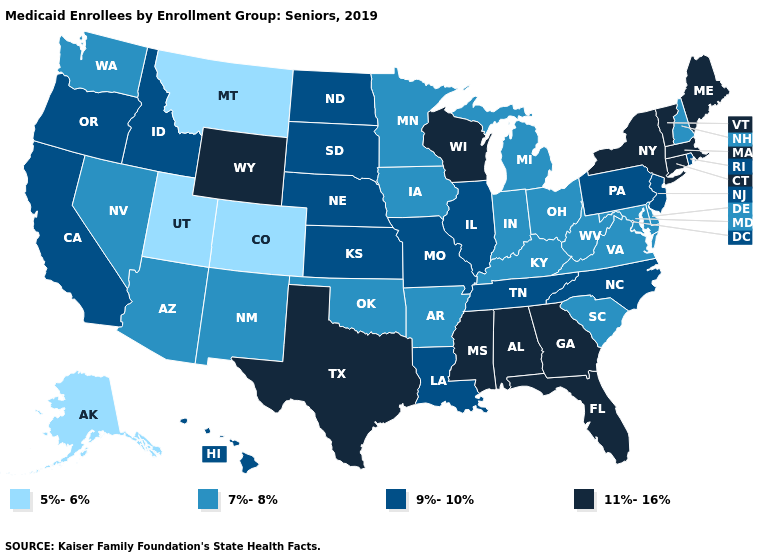Among the states that border South Dakota , does Wyoming have the highest value?
Short answer required. Yes. What is the value of Ohio?
Answer briefly. 7%-8%. Does the map have missing data?
Give a very brief answer. No. What is the value of Alaska?
Write a very short answer. 5%-6%. Among the states that border Texas , which have the lowest value?
Be succinct. Arkansas, New Mexico, Oklahoma. Name the states that have a value in the range 5%-6%?
Give a very brief answer. Alaska, Colorado, Montana, Utah. Name the states that have a value in the range 9%-10%?
Be succinct. California, Hawaii, Idaho, Illinois, Kansas, Louisiana, Missouri, Nebraska, New Jersey, North Carolina, North Dakota, Oregon, Pennsylvania, Rhode Island, South Dakota, Tennessee. Does the map have missing data?
Be succinct. No. Name the states that have a value in the range 5%-6%?
Give a very brief answer. Alaska, Colorado, Montana, Utah. What is the value of Connecticut?
Keep it brief. 11%-16%. Which states have the highest value in the USA?
Be succinct. Alabama, Connecticut, Florida, Georgia, Maine, Massachusetts, Mississippi, New York, Texas, Vermont, Wisconsin, Wyoming. What is the lowest value in states that border Florida?
Quick response, please. 11%-16%. Does Pennsylvania have a higher value than Nevada?
Answer briefly. Yes. What is the value of Wisconsin?
Give a very brief answer. 11%-16%. 